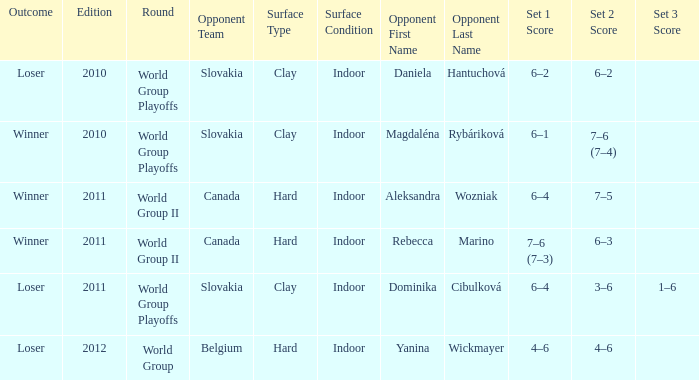In which game edition did they compete on a clay surface and ultimately produce a winner? 2010.0. 